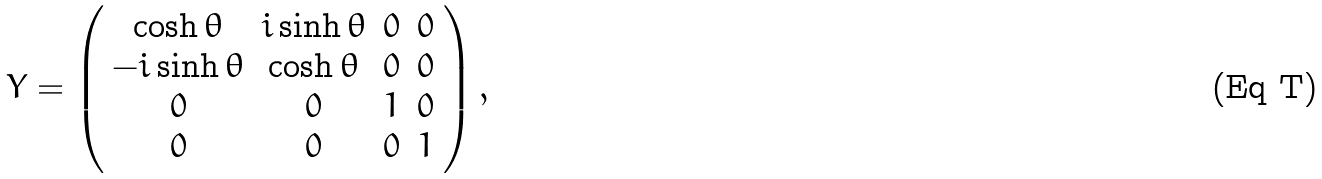Convert formula to latex. <formula><loc_0><loc_0><loc_500><loc_500>Y = \left ( \begin{array} { c c c c } \cosh { \theta } & i \sinh { \theta } & 0 & 0 \\ - i \sinh { \theta } & \cosh { \theta } & 0 & 0 \\ 0 & 0 & 1 & 0 \\ 0 & 0 & 0 & 1 \end{array} \right ) ,</formula> 